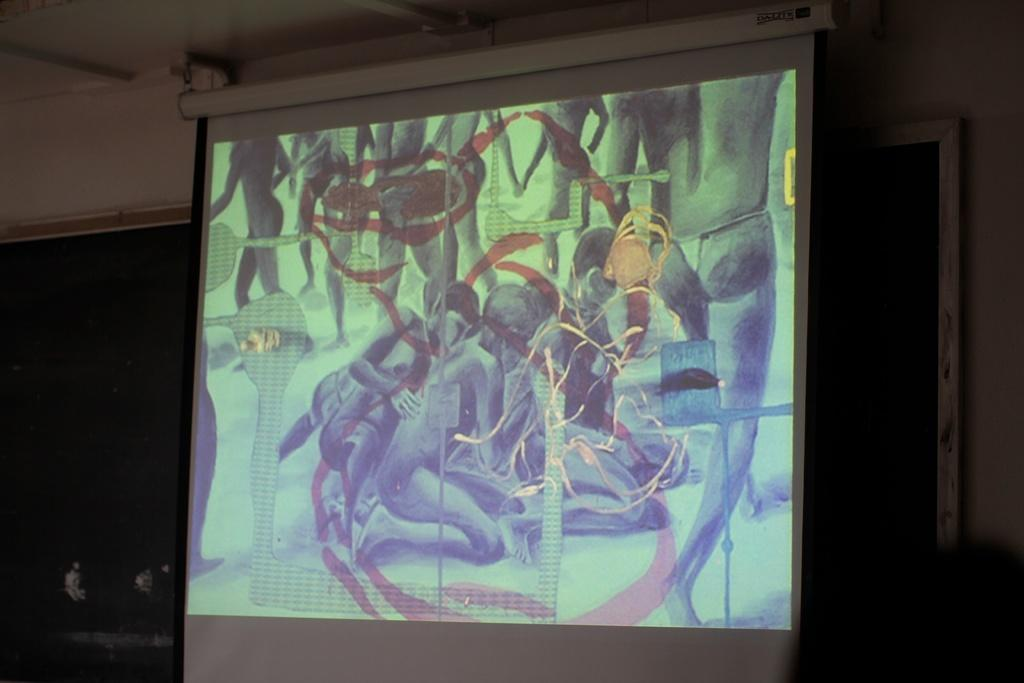What is the main object in the image? There is a projector screen in the image. What is attached to the back of the screen? There is a board on the back of the screen. What can be seen on the screen? There is a display visible on the screen. What type of care does the thumb receive in the image? There is no thumb present in the image, so it is not possible to determine what type of care it might receive. 